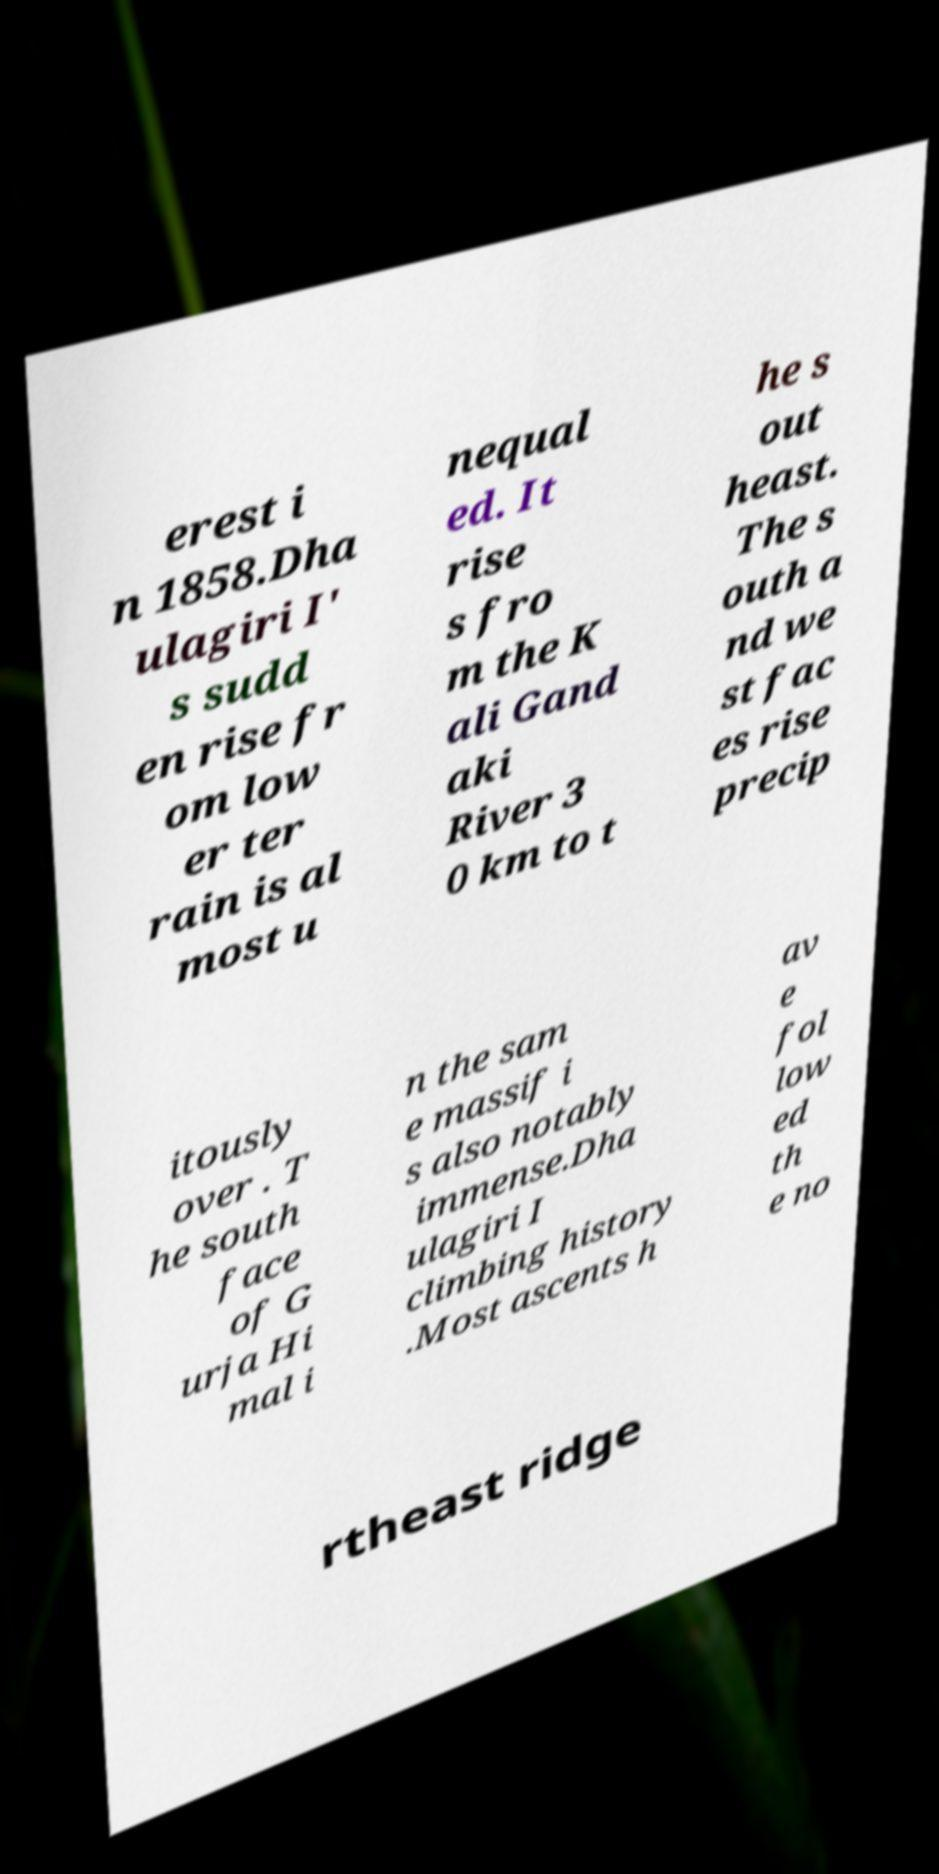Could you assist in decoding the text presented in this image and type it out clearly? erest i n 1858.Dha ulagiri I' s sudd en rise fr om low er ter rain is al most u nequal ed. It rise s fro m the K ali Gand aki River 3 0 km to t he s out heast. The s outh a nd we st fac es rise precip itously over . T he south face of G urja Hi mal i n the sam e massif i s also notably immense.Dha ulagiri I climbing history .Most ascents h av e fol low ed th e no rtheast ridge 